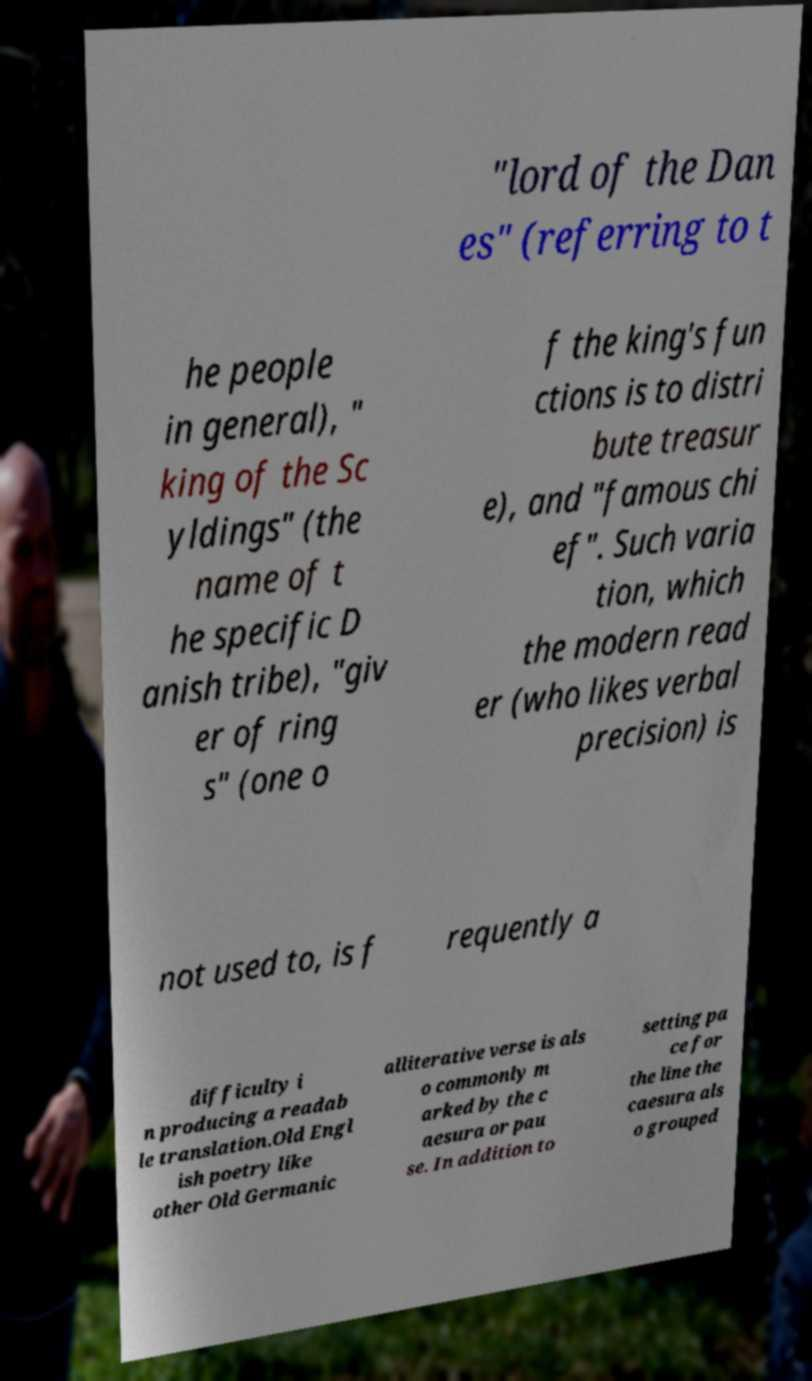Could you assist in decoding the text presented in this image and type it out clearly? "lord of the Dan es" (referring to t he people in general), " king of the Sc yldings" (the name of t he specific D anish tribe), "giv er of ring s" (one o f the king's fun ctions is to distri bute treasur e), and "famous chi ef". Such varia tion, which the modern read er (who likes verbal precision) is not used to, is f requently a difficulty i n producing a readab le translation.Old Engl ish poetry like other Old Germanic alliterative verse is als o commonly m arked by the c aesura or pau se. In addition to setting pa ce for the line the caesura als o grouped 